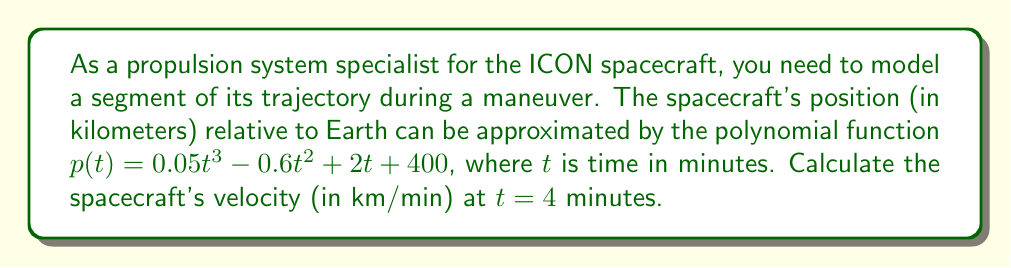Can you solve this math problem? To solve this problem, we need to follow these steps:

1) The position function is given as:
   $$p(t) = 0.05t^3 - 0.6t^2 + 2t + 400$$

2) To find the velocity function, we need to take the derivative of the position function. The velocity is the rate of change of position with respect to time.
   $$v(t) = \frac{d}{dt}p(t)$$

3) Using the power rule of differentiation:
   $$v(t) = 0.15t^2 - 1.2t + 2$$

4) Now that we have the velocity function, we can calculate the velocity at $t = 4$ minutes by substituting $t = 4$ into the equation:

   $$v(4) = 0.15(4)^2 - 1.2(4) + 2$$
   $$v(4) = 0.15(16) - 4.8 + 2$$
   $$v(4) = 2.4 - 4.8 + 2$$
   $$v(4) = -0.4$$

5) Therefore, the velocity of the spacecraft at $t = 4$ minutes is -0.4 km/min.

The negative value indicates that the spacecraft is moving in the opposite direction of the positive axis at this moment in time.
Answer: $-0.4$ km/min 